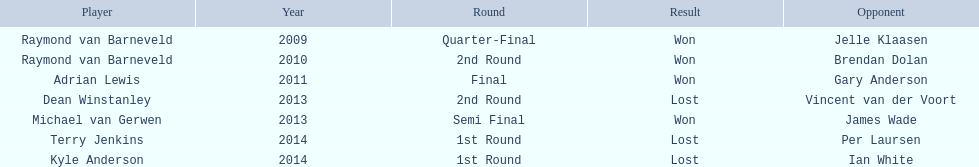What are all the years? 2009, 2010, 2011, 2013, 2013, 2014, 2014. Of these, which ones are 2014? 2014, 2014. Of these dates which one is associated with a player other than kyle anderson? 2014. What is the player name associated with this year? Terry Jenkins. Can you list all the players? Raymond van Barneveld, Raymond van Barneveld, Adrian Lewis, Dean Winstanley, Michael van Gerwen, Terry Jenkins, Kyle Anderson. When were they involved? 2009, 2010, 2011, 2013, 2013, 2014, 2014. Also, who was the player active in 2011? Adrian Lewis. 